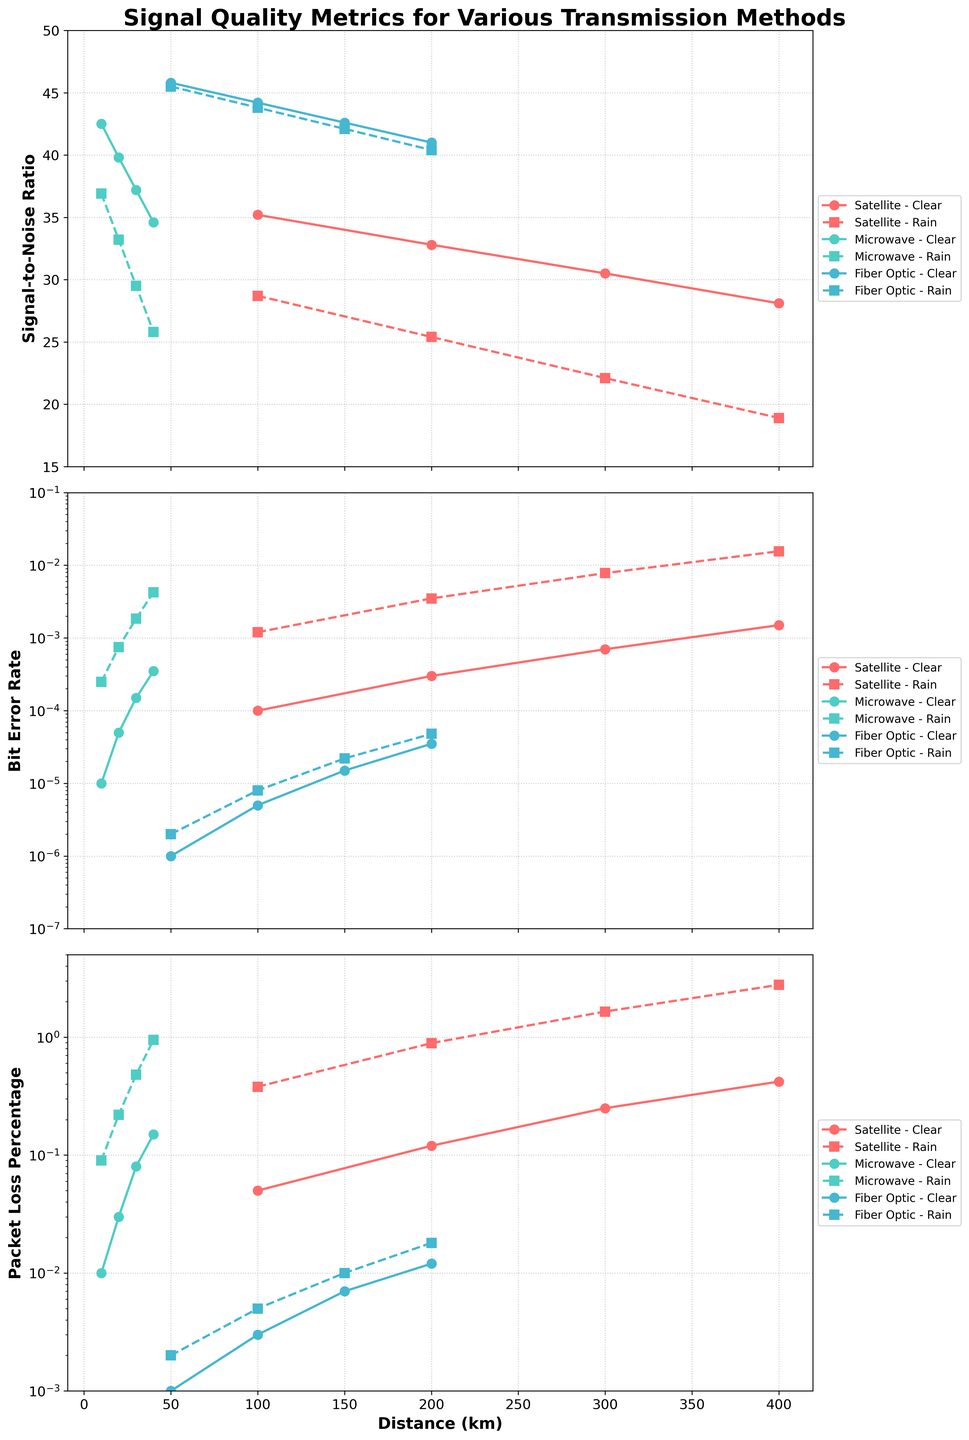Which transmission method shows the highest signal-to-noise ratio under clear weather conditions? To determine this, look at the line corresponding to each transmission method (Satellite, Microwave, Fiber Optic) in clear weather on the Signal-to-Noise Ratio subplot. The Fiber Optic line reaches above 45, the highest among all methods.
Answer: Fiber Optic How does the bit error rate for Microwave transmission change with distance in rainy weather? On the Bit Error Rate subplot, follow the Microwave line with the dashed marker representing rainy weather. The bit error rate increases from 0.00025 at 10 km to 0.00425 at 40 km.
Answer: Increases What is the discrepancy in packet loss percentage between Satellite and Fiber Optic transmission methods at a distance of 100 km in clear weather? Compare the corresponding points for each method on the Packet Loss Percentage subplot. For Satellite at 100 km, the packet loss is 0.05%, while for Fiber Optic at 100 km, it's 0.003%. Compute the difference: 0.05 - 0.003 = 0.047
Answer: 0.047% Which method and condition combination shows the steepest decline in signal-to-noise ratio as distance increases? Identify the lines with high downward slopes in the Signal-to-Noise Ratio subplot. The Satellite method in rainy weather displays a steep decline from above 28 at 100 km to below 20 at 400 km.
Answer: Satellite - Rain How much greater is the bit error rate for Satellite transmission at 400 km compared to Microwave transmission at the same distance in clear weather? Look at the Bit Error Rate subplot and compare the values for both. Satellite at 400 km is 0.0015, while Microwave at 40 km (scaled to the same x-axis units as other methods) is 0.00035. Compute the ratio: 0.0015 / 0.00035 = 4.29
Answer: 4.29 times What is the trend in packet loss percentage for Fiber Optic transmissions across different distances during rainy weather? Follow the Fiber Optic line marked for rainy weather in the Packet Loss Percentage subplot. The packet loss percentage increases from 0.002% at 50 km to 0.018% at 200 km.
Answer: Increases At what distance does the Satellite transmission in clear weather show a signal-to-noise ratio just below 30? Check the Satellite line for clear weather in the Signal-to-Noise Ratio subplot. The ratio drops below 30 between 200 km and 300 km.
Answer: Between 200 km and 300 km Under which condition does the bit error rate for Fiber Optic transmission remain consistently low, and what is its range? Follow the Fiber Optic lines in the Bit Error Rate subplot. Both clear and rainy conditions show low bit error rates, ranging from about 0.000001 to 0.000048.
Answer: Clear and Rain, 0.000001 to 0.000048 